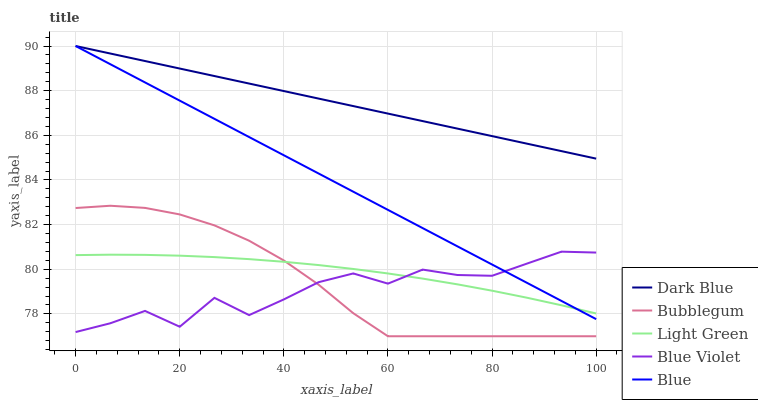Does Blue Violet have the minimum area under the curve?
Answer yes or no. Yes. Does Dark Blue have the maximum area under the curve?
Answer yes or no. Yes. Does Light Green have the minimum area under the curve?
Answer yes or no. No. Does Light Green have the maximum area under the curve?
Answer yes or no. No. Is Blue the smoothest?
Answer yes or no. Yes. Is Blue Violet the roughest?
Answer yes or no. Yes. Is Dark Blue the smoothest?
Answer yes or no. No. Is Dark Blue the roughest?
Answer yes or no. No. Does Light Green have the lowest value?
Answer yes or no. No. Does Blue have the highest value?
Answer yes or no. Yes. Does Light Green have the highest value?
Answer yes or no. No. Is Blue Violet less than Dark Blue?
Answer yes or no. Yes. Is Blue greater than Bubblegum?
Answer yes or no. Yes. Does Blue Violet intersect Bubblegum?
Answer yes or no. Yes. Is Blue Violet less than Bubblegum?
Answer yes or no. No. Is Blue Violet greater than Bubblegum?
Answer yes or no. No. Does Blue Violet intersect Dark Blue?
Answer yes or no. No. 